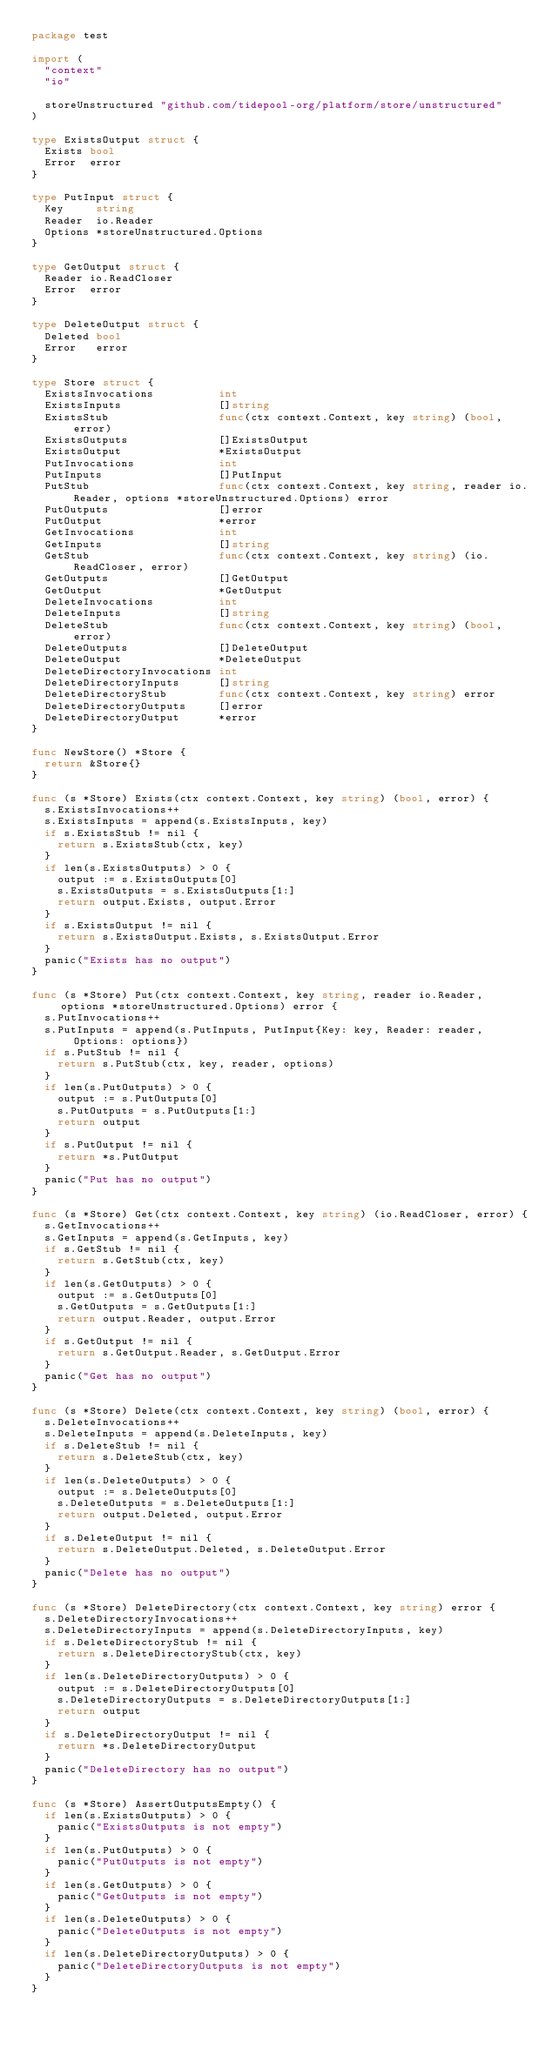Convert code to text. <code><loc_0><loc_0><loc_500><loc_500><_Go_>package test

import (
	"context"
	"io"

	storeUnstructured "github.com/tidepool-org/platform/store/unstructured"
)

type ExistsOutput struct {
	Exists bool
	Error  error
}

type PutInput struct {
	Key     string
	Reader  io.Reader
	Options *storeUnstructured.Options
}

type GetOutput struct {
	Reader io.ReadCloser
	Error  error
}

type DeleteOutput struct {
	Deleted bool
	Error   error
}

type Store struct {
	ExistsInvocations          int
	ExistsInputs               []string
	ExistsStub                 func(ctx context.Context, key string) (bool, error)
	ExistsOutputs              []ExistsOutput
	ExistsOutput               *ExistsOutput
	PutInvocations             int
	PutInputs                  []PutInput
	PutStub                    func(ctx context.Context, key string, reader io.Reader, options *storeUnstructured.Options) error
	PutOutputs                 []error
	PutOutput                  *error
	GetInvocations             int
	GetInputs                  []string
	GetStub                    func(ctx context.Context, key string) (io.ReadCloser, error)
	GetOutputs                 []GetOutput
	GetOutput                  *GetOutput
	DeleteInvocations          int
	DeleteInputs               []string
	DeleteStub                 func(ctx context.Context, key string) (bool, error)
	DeleteOutputs              []DeleteOutput
	DeleteOutput               *DeleteOutput
	DeleteDirectoryInvocations int
	DeleteDirectoryInputs      []string
	DeleteDirectoryStub        func(ctx context.Context, key string) error
	DeleteDirectoryOutputs     []error
	DeleteDirectoryOutput      *error
}

func NewStore() *Store {
	return &Store{}
}

func (s *Store) Exists(ctx context.Context, key string) (bool, error) {
	s.ExistsInvocations++
	s.ExistsInputs = append(s.ExistsInputs, key)
	if s.ExistsStub != nil {
		return s.ExistsStub(ctx, key)
	}
	if len(s.ExistsOutputs) > 0 {
		output := s.ExistsOutputs[0]
		s.ExistsOutputs = s.ExistsOutputs[1:]
		return output.Exists, output.Error
	}
	if s.ExistsOutput != nil {
		return s.ExistsOutput.Exists, s.ExistsOutput.Error
	}
	panic("Exists has no output")
}

func (s *Store) Put(ctx context.Context, key string, reader io.Reader, options *storeUnstructured.Options) error {
	s.PutInvocations++
	s.PutInputs = append(s.PutInputs, PutInput{Key: key, Reader: reader, Options: options})
	if s.PutStub != nil {
		return s.PutStub(ctx, key, reader, options)
	}
	if len(s.PutOutputs) > 0 {
		output := s.PutOutputs[0]
		s.PutOutputs = s.PutOutputs[1:]
		return output
	}
	if s.PutOutput != nil {
		return *s.PutOutput
	}
	panic("Put has no output")
}

func (s *Store) Get(ctx context.Context, key string) (io.ReadCloser, error) {
	s.GetInvocations++
	s.GetInputs = append(s.GetInputs, key)
	if s.GetStub != nil {
		return s.GetStub(ctx, key)
	}
	if len(s.GetOutputs) > 0 {
		output := s.GetOutputs[0]
		s.GetOutputs = s.GetOutputs[1:]
		return output.Reader, output.Error
	}
	if s.GetOutput != nil {
		return s.GetOutput.Reader, s.GetOutput.Error
	}
	panic("Get has no output")
}

func (s *Store) Delete(ctx context.Context, key string) (bool, error) {
	s.DeleteInvocations++
	s.DeleteInputs = append(s.DeleteInputs, key)
	if s.DeleteStub != nil {
		return s.DeleteStub(ctx, key)
	}
	if len(s.DeleteOutputs) > 0 {
		output := s.DeleteOutputs[0]
		s.DeleteOutputs = s.DeleteOutputs[1:]
		return output.Deleted, output.Error
	}
	if s.DeleteOutput != nil {
		return s.DeleteOutput.Deleted, s.DeleteOutput.Error
	}
	panic("Delete has no output")
}

func (s *Store) DeleteDirectory(ctx context.Context, key string) error {
	s.DeleteDirectoryInvocations++
	s.DeleteDirectoryInputs = append(s.DeleteDirectoryInputs, key)
	if s.DeleteDirectoryStub != nil {
		return s.DeleteDirectoryStub(ctx, key)
	}
	if len(s.DeleteDirectoryOutputs) > 0 {
		output := s.DeleteDirectoryOutputs[0]
		s.DeleteDirectoryOutputs = s.DeleteDirectoryOutputs[1:]
		return output
	}
	if s.DeleteDirectoryOutput != nil {
		return *s.DeleteDirectoryOutput
	}
	panic("DeleteDirectory has no output")
}

func (s *Store) AssertOutputsEmpty() {
	if len(s.ExistsOutputs) > 0 {
		panic("ExistsOutputs is not empty")
	}
	if len(s.PutOutputs) > 0 {
		panic("PutOutputs is not empty")
	}
	if len(s.GetOutputs) > 0 {
		panic("GetOutputs is not empty")
	}
	if len(s.DeleteOutputs) > 0 {
		panic("DeleteOutputs is not empty")
	}
	if len(s.DeleteDirectoryOutputs) > 0 {
		panic("DeleteDirectoryOutputs is not empty")
	}
}
</code> 